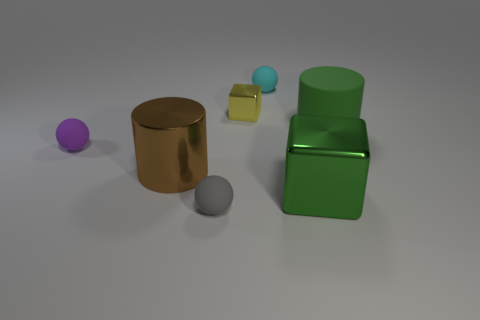Can you describe the materials the objects seem to be made of? Certainly. The objects in the image appear to have different materials. The spherical object is purple, probably made of a matte plastic. The cylindrical object has a metallic sheen, suggesting it could be made of metal. The cube-like object is also matte and yellow, resembling a plastic material. The small ball in front of the green block has the same plastic look as the purple sphere, but is blue. Lastly, the green object has a glossy finish, giving it the appearance of painted metal. 